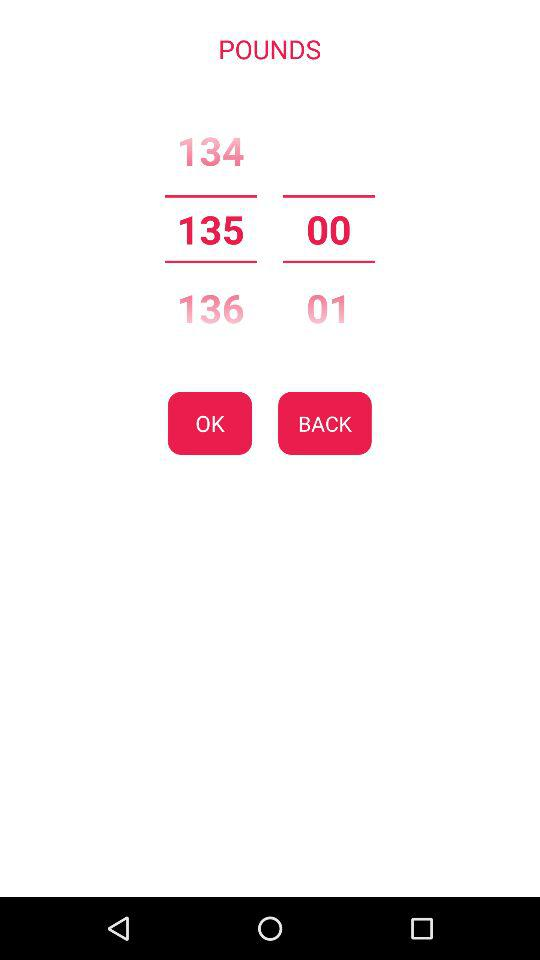What is the number of pounds? The number of pounds is 135 00. 